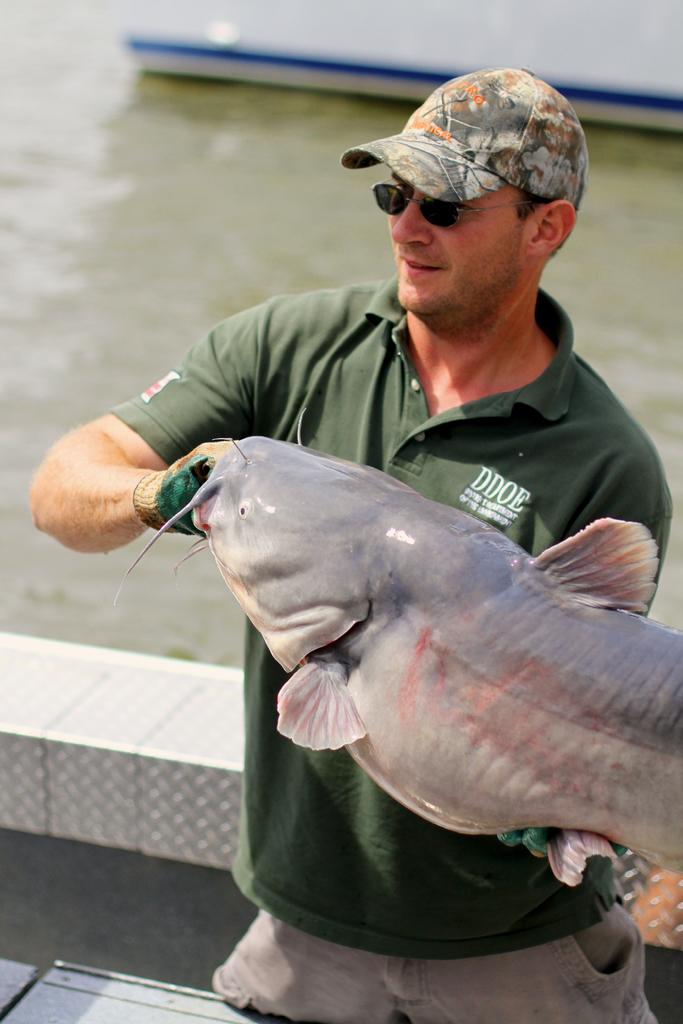What is the person in the image wearing on their head? The person is wearing a cap. What other protective gear is the person wearing in the image? The person is wearing gloves and goggles. What is the person holding in the image? The person is holding a fish. Can you describe the background of the image? The background of the image is blurry. What type of environment is visible in the image? There is water visible in the image. How many objects can be seen in the image besides the person and the fish? There are a few objects in the image. What type of cheese is being used to burn the boats in the image? There is no cheese or boats present in the image, and therefore no such activity can be observed. 